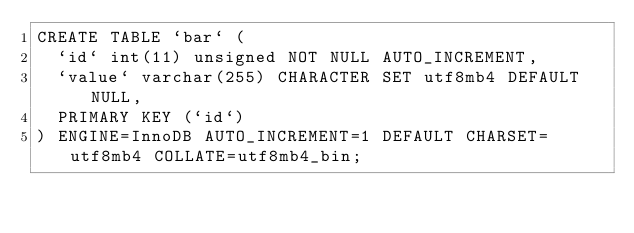<code> <loc_0><loc_0><loc_500><loc_500><_SQL_>CREATE TABLE `bar` (
  `id` int(11) unsigned NOT NULL AUTO_INCREMENT,
  `value` varchar(255) CHARACTER SET utf8mb4 DEFAULT NULL,
  PRIMARY KEY (`id`)
) ENGINE=InnoDB AUTO_INCREMENT=1 DEFAULT CHARSET=utf8mb4 COLLATE=utf8mb4_bin;
</code> 